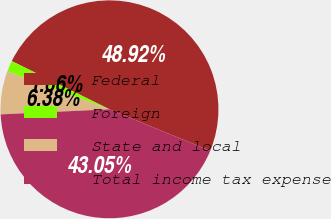<chart> <loc_0><loc_0><loc_500><loc_500><pie_chart><fcel>Federal<fcel>Foreign<fcel>State and local<fcel>Total income tax expense<nl><fcel>48.92%<fcel>1.66%<fcel>6.38%<fcel>43.05%<nl></chart> 